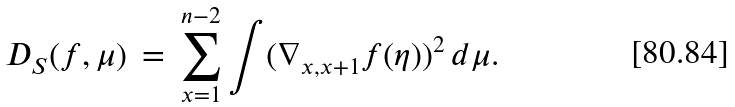<formula> <loc_0><loc_0><loc_500><loc_500>D _ { S } ( f , \mu ) \, = \, \sum _ { x = 1 } ^ { n - 2 } \int ( \nabla _ { x , x + 1 } f ( \eta ) ) ^ { 2 } \, d \mu .</formula> 